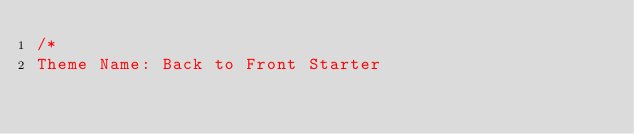Convert code to text. <code><loc_0><loc_0><loc_500><loc_500><_CSS_>/*
Theme Name: Back to Front Starter</code> 